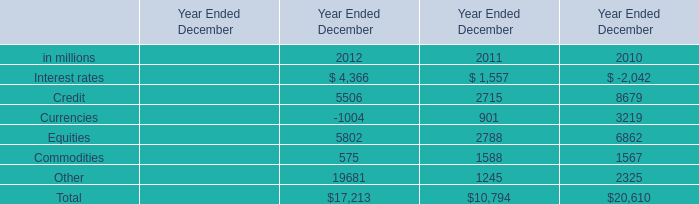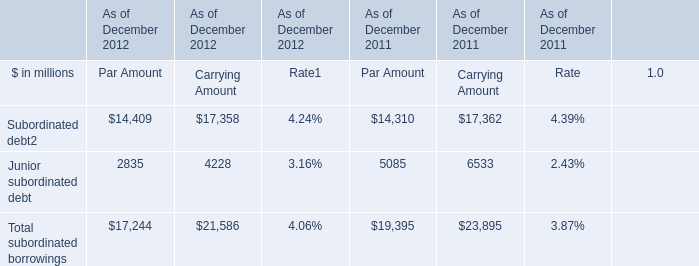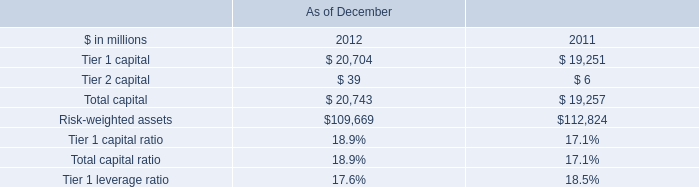what's the total amount of Tier 1 capital of As of December 2012 is, and Other of Year Ended December 2010 ? 
Computations: (20704.0 + 2325.0)
Answer: 23029.0. 